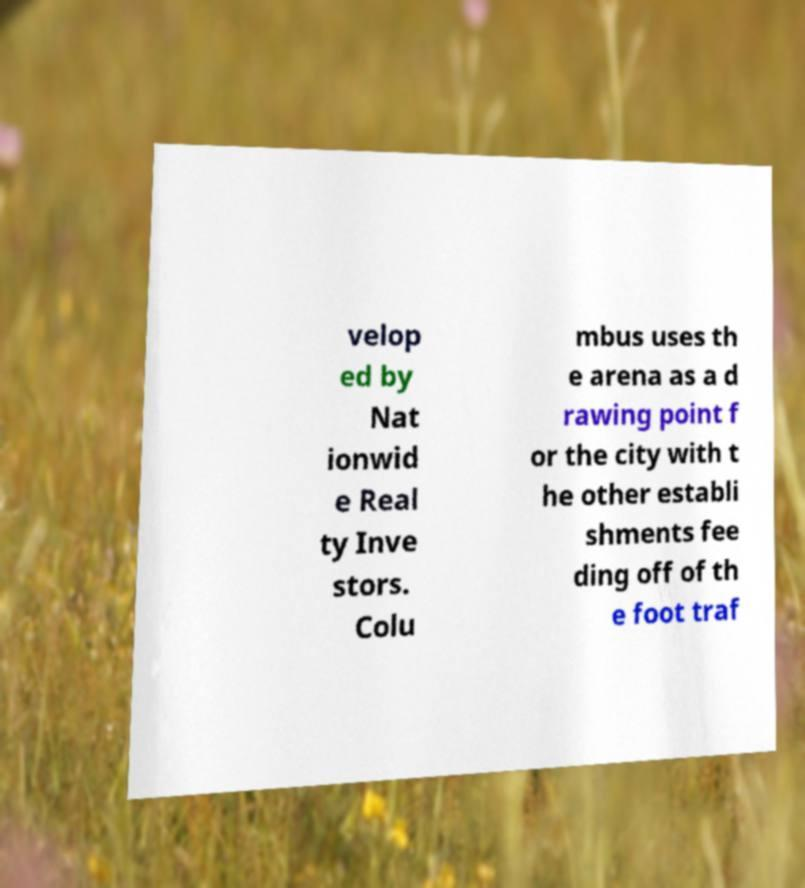Please identify and transcribe the text found in this image. velop ed by Nat ionwid e Real ty Inve stors. Colu mbus uses th e arena as a d rawing point f or the city with t he other establi shments fee ding off of th e foot traf 